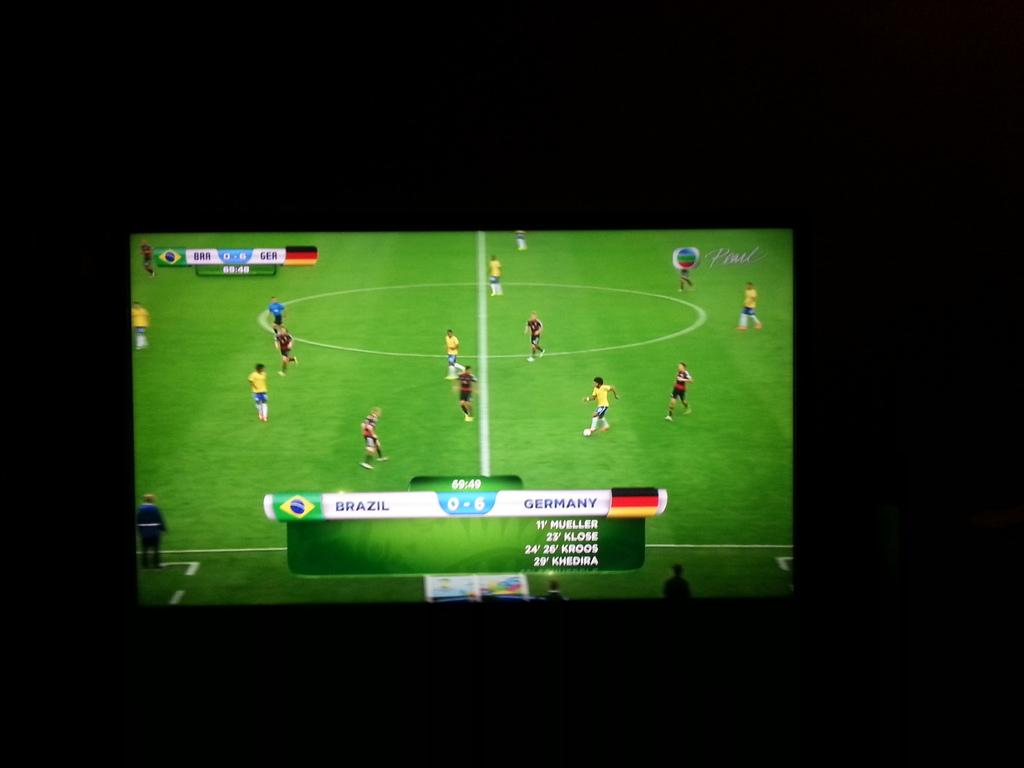<image>
Give a short and clear explanation of the subsequent image. Television shot of a soccer game where Brazil and Germany are the opposing teams. 